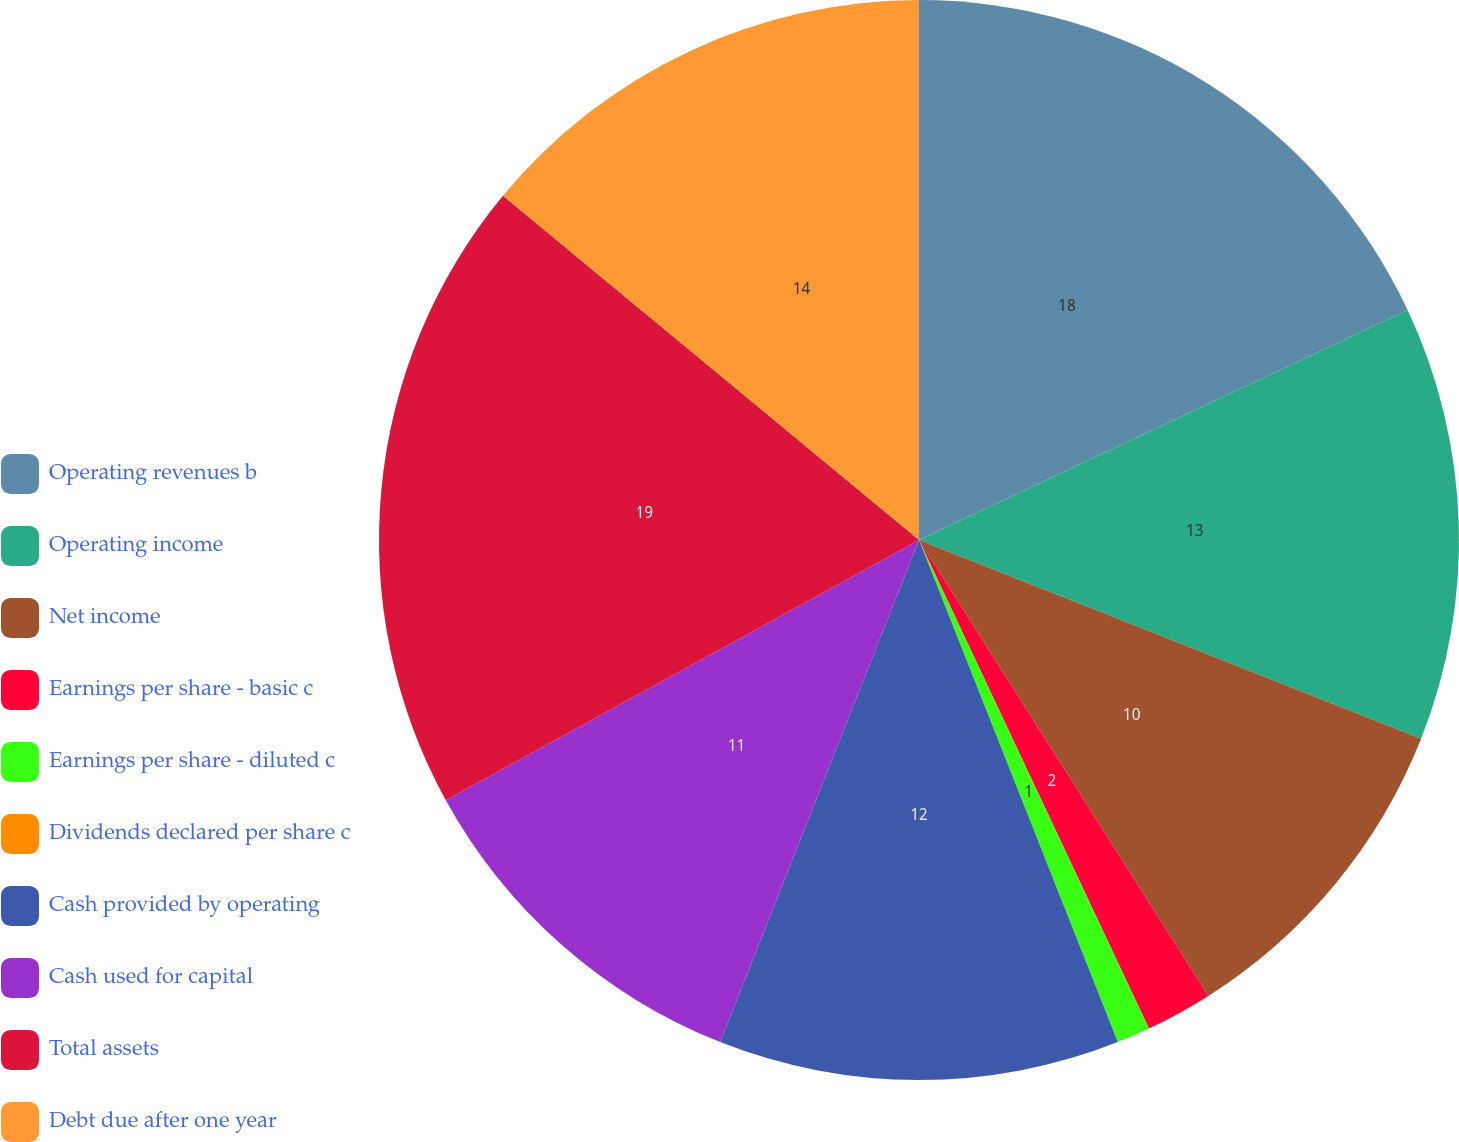Convert chart. <chart><loc_0><loc_0><loc_500><loc_500><pie_chart><fcel>Operating revenues b<fcel>Operating income<fcel>Net income<fcel>Earnings per share - basic c<fcel>Earnings per share - diluted c<fcel>Dividends declared per share c<fcel>Cash provided by operating<fcel>Cash used for capital<fcel>Total assets<fcel>Debt due after one year<nl><fcel>18.0%<fcel>13.0%<fcel>10.0%<fcel>2.0%<fcel>1.0%<fcel>0.0%<fcel>12.0%<fcel>11.0%<fcel>19.0%<fcel>14.0%<nl></chart> 